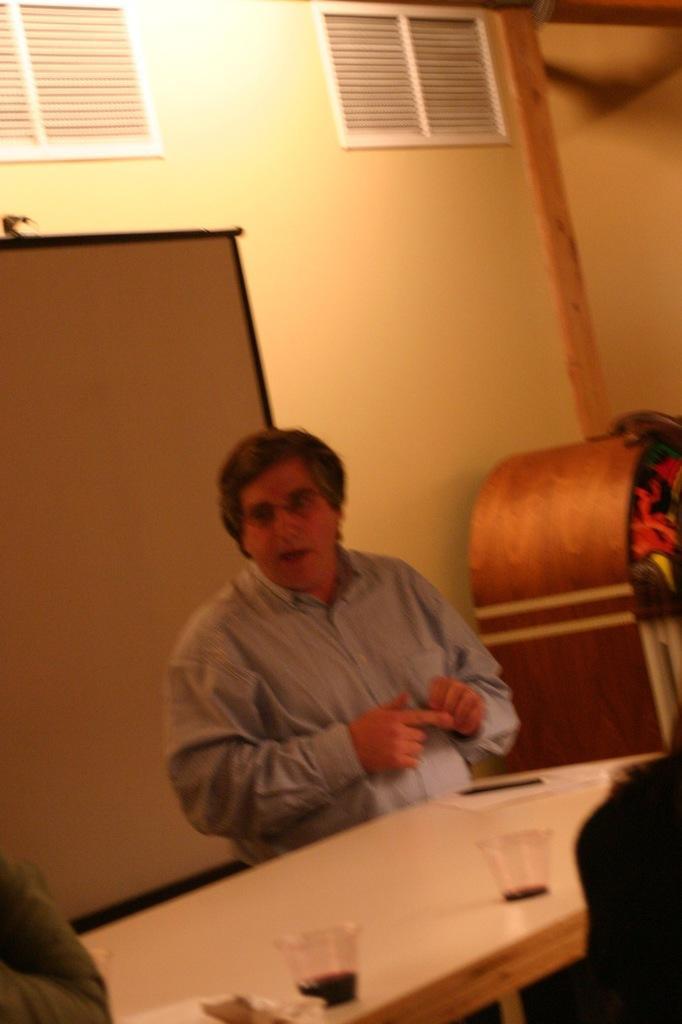Please provide a concise description of this image. In this image there is a person on the left corner. There is a person and wooden object the right corner. There is a table with glasses and objects on it and a person in the foreground. There is a wall in the background. 